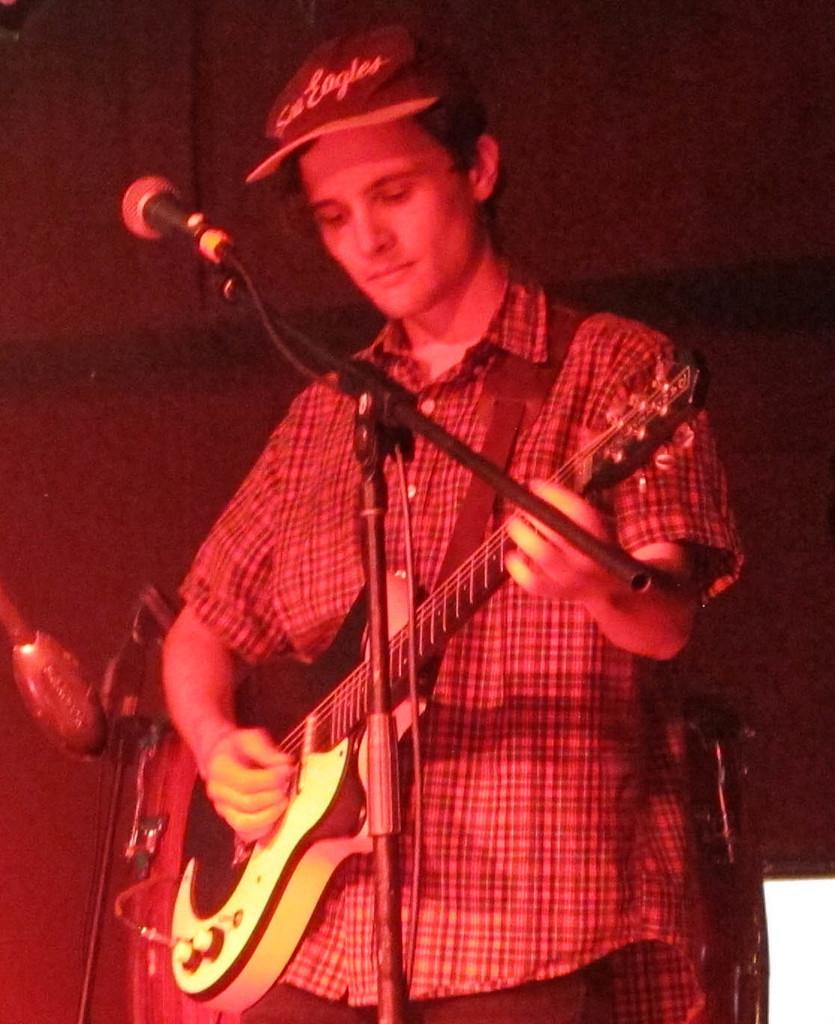What is the person in the image doing? The person is playing a guitar. What is the person wearing on their head? The person is wearing a cap. What object is present at the left side of the image? There is a microphone at the left side of the image. What can be seen in the background of the image? There is a wall in the background of the image. Where is the throne located in the image? There is no throne present in the image. What type of birth can be seen happening in the image? There is no birth depicted in the image. 